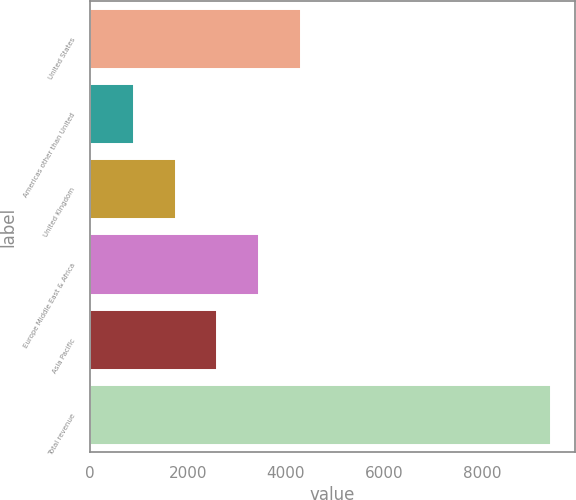<chart> <loc_0><loc_0><loc_500><loc_500><bar_chart><fcel>United States<fcel>Americas other than United<fcel>United Kingdom<fcel>Europe Middle East & Africa<fcel>Asia Pacific<fcel>Total revenue<nl><fcel>4303<fcel>899<fcel>1750<fcel>3452<fcel>2601<fcel>9409<nl></chart> 